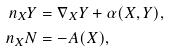Convert formula to latex. <formula><loc_0><loc_0><loc_500><loc_500>\ n _ { X } Y & = \nabla _ { X } Y + \alpha ( X , Y ) , \\ \ n _ { X } N & = - A ( X ) ,</formula> 